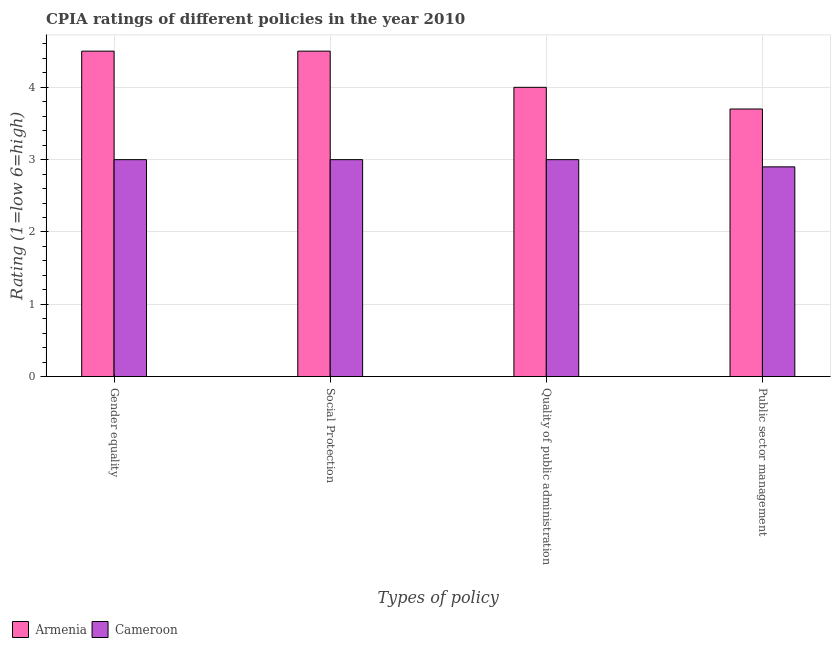Are the number of bars on each tick of the X-axis equal?
Provide a short and direct response. Yes. How many bars are there on the 2nd tick from the left?
Your answer should be compact. 2. What is the label of the 3rd group of bars from the left?
Your response must be concise. Quality of public administration. Across all countries, what is the minimum cpia rating of gender equality?
Keep it short and to the point. 3. In which country was the cpia rating of social protection maximum?
Your answer should be very brief. Armenia. In which country was the cpia rating of gender equality minimum?
Provide a short and direct response. Cameroon. What is the total cpia rating of gender equality in the graph?
Your response must be concise. 7.5. What is the difference between the cpia rating of quality of public administration in Cameroon and the cpia rating of social protection in Armenia?
Offer a very short reply. -1.5. What is the average cpia rating of public sector management per country?
Keep it short and to the point. 3.3. What is the difference between the cpia rating of public sector management and cpia rating of social protection in Cameroon?
Your answer should be compact. -0.1. What is the ratio of the cpia rating of public sector management in Cameroon to that in Armenia?
Offer a very short reply. 0.78. Is it the case that in every country, the sum of the cpia rating of quality of public administration and cpia rating of gender equality is greater than the sum of cpia rating of social protection and cpia rating of public sector management?
Provide a short and direct response. No. What does the 2nd bar from the left in Public sector management represents?
Offer a terse response. Cameroon. What does the 1st bar from the right in Gender equality represents?
Provide a short and direct response. Cameroon. Are all the bars in the graph horizontal?
Provide a succinct answer. No. How many countries are there in the graph?
Keep it short and to the point. 2. Does the graph contain any zero values?
Give a very brief answer. No. Where does the legend appear in the graph?
Offer a terse response. Bottom left. How many legend labels are there?
Make the answer very short. 2. How are the legend labels stacked?
Your answer should be compact. Horizontal. What is the title of the graph?
Your answer should be very brief. CPIA ratings of different policies in the year 2010. What is the label or title of the X-axis?
Keep it short and to the point. Types of policy. What is the label or title of the Y-axis?
Offer a very short reply. Rating (1=low 6=high). What is the Rating (1=low 6=high) of Armenia in Gender equality?
Make the answer very short. 4.5. What is the Rating (1=low 6=high) of Cameroon in Social Protection?
Offer a very short reply. 3. What is the Rating (1=low 6=high) of Cameroon in Quality of public administration?
Give a very brief answer. 3. What is the Rating (1=low 6=high) of Armenia in Public sector management?
Make the answer very short. 3.7. Across all Types of policy, what is the maximum Rating (1=low 6=high) of Armenia?
Provide a succinct answer. 4.5. Across all Types of policy, what is the minimum Rating (1=low 6=high) in Cameroon?
Ensure brevity in your answer.  2.9. What is the difference between the Rating (1=low 6=high) in Cameroon in Gender equality and that in Social Protection?
Your answer should be compact. 0. What is the difference between the Rating (1=low 6=high) of Armenia in Gender equality and that in Public sector management?
Keep it short and to the point. 0.8. What is the difference between the Rating (1=low 6=high) in Cameroon in Gender equality and that in Public sector management?
Offer a terse response. 0.1. What is the difference between the Rating (1=low 6=high) in Armenia in Social Protection and that in Public sector management?
Ensure brevity in your answer.  0.8. What is the difference between the Rating (1=low 6=high) of Cameroon in Social Protection and that in Public sector management?
Your answer should be very brief. 0.1. What is the difference between the Rating (1=low 6=high) of Armenia in Quality of public administration and that in Public sector management?
Ensure brevity in your answer.  0.3. What is the difference between the Rating (1=low 6=high) of Armenia in Gender equality and the Rating (1=low 6=high) of Cameroon in Social Protection?
Offer a terse response. 1.5. What is the difference between the Rating (1=low 6=high) in Armenia in Social Protection and the Rating (1=low 6=high) in Cameroon in Public sector management?
Your answer should be very brief. 1.6. What is the difference between the Rating (1=low 6=high) in Armenia in Quality of public administration and the Rating (1=low 6=high) in Cameroon in Public sector management?
Make the answer very short. 1.1. What is the average Rating (1=low 6=high) of Armenia per Types of policy?
Provide a succinct answer. 4.17. What is the average Rating (1=low 6=high) in Cameroon per Types of policy?
Keep it short and to the point. 2.98. What is the difference between the Rating (1=low 6=high) of Armenia and Rating (1=low 6=high) of Cameroon in Gender equality?
Make the answer very short. 1.5. What is the difference between the Rating (1=low 6=high) in Armenia and Rating (1=low 6=high) in Cameroon in Social Protection?
Provide a short and direct response. 1.5. What is the difference between the Rating (1=low 6=high) of Armenia and Rating (1=low 6=high) of Cameroon in Quality of public administration?
Provide a short and direct response. 1. What is the difference between the Rating (1=low 6=high) of Armenia and Rating (1=low 6=high) of Cameroon in Public sector management?
Keep it short and to the point. 0.8. What is the ratio of the Rating (1=low 6=high) in Armenia in Gender equality to that in Social Protection?
Your answer should be compact. 1. What is the ratio of the Rating (1=low 6=high) in Cameroon in Gender equality to that in Social Protection?
Your response must be concise. 1. What is the ratio of the Rating (1=low 6=high) in Armenia in Gender equality to that in Quality of public administration?
Offer a terse response. 1.12. What is the ratio of the Rating (1=low 6=high) of Armenia in Gender equality to that in Public sector management?
Make the answer very short. 1.22. What is the ratio of the Rating (1=low 6=high) in Cameroon in Gender equality to that in Public sector management?
Keep it short and to the point. 1.03. What is the ratio of the Rating (1=low 6=high) in Cameroon in Social Protection to that in Quality of public administration?
Keep it short and to the point. 1. What is the ratio of the Rating (1=low 6=high) of Armenia in Social Protection to that in Public sector management?
Provide a succinct answer. 1.22. What is the ratio of the Rating (1=low 6=high) in Cameroon in Social Protection to that in Public sector management?
Provide a succinct answer. 1.03. What is the ratio of the Rating (1=low 6=high) in Armenia in Quality of public administration to that in Public sector management?
Your answer should be compact. 1.08. What is the ratio of the Rating (1=low 6=high) in Cameroon in Quality of public administration to that in Public sector management?
Provide a succinct answer. 1.03. What is the difference between the highest and the second highest Rating (1=low 6=high) of Armenia?
Ensure brevity in your answer.  0. What is the difference between the highest and the lowest Rating (1=low 6=high) of Armenia?
Make the answer very short. 0.8. What is the difference between the highest and the lowest Rating (1=low 6=high) of Cameroon?
Give a very brief answer. 0.1. 